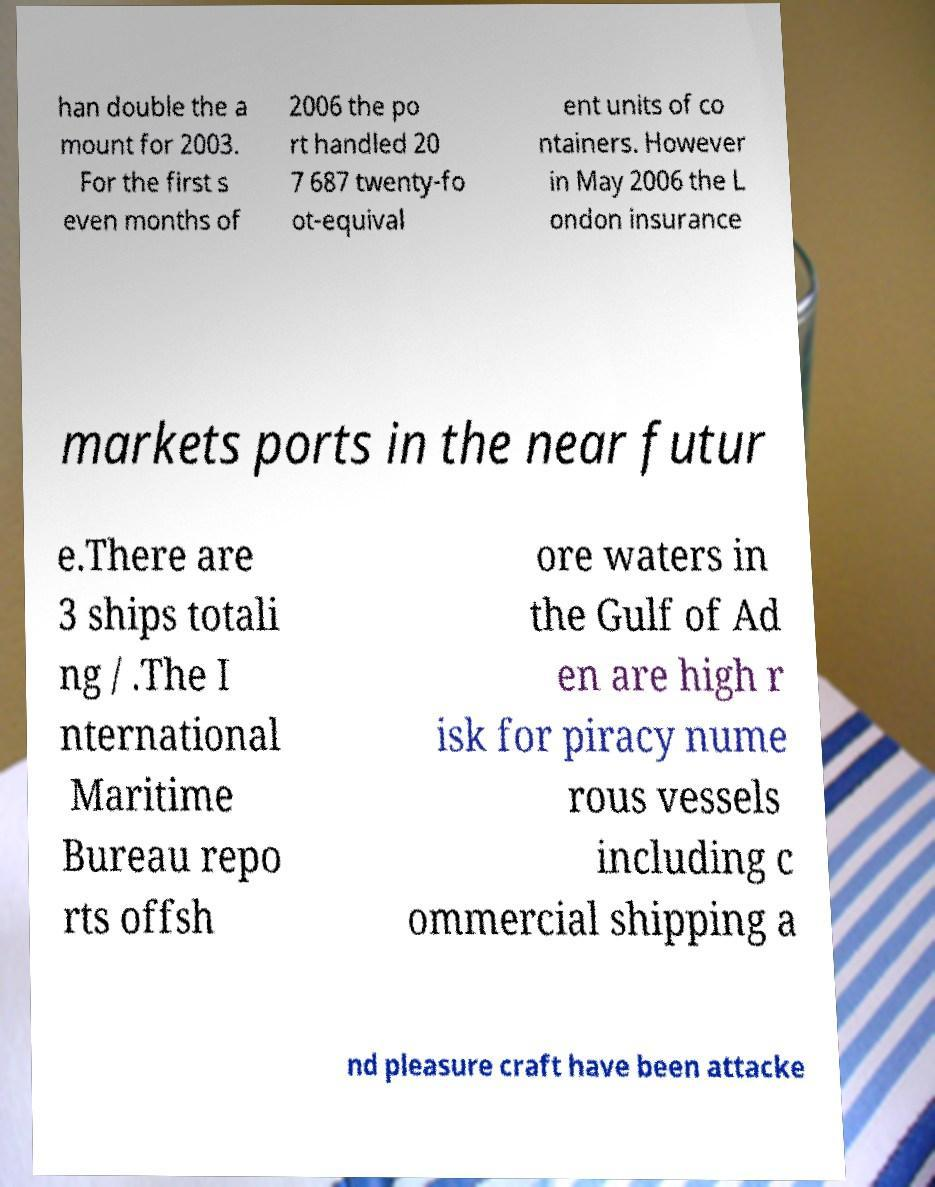There's text embedded in this image that I need extracted. Can you transcribe it verbatim? han double the a mount for 2003. For the first s even months of 2006 the po rt handled 20 7 687 twenty-fo ot-equival ent units of co ntainers. However in May 2006 the L ondon insurance markets ports in the near futur e.There are 3 ships totali ng / .The I nternational Maritime Bureau repo rts offsh ore waters in the Gulf of Ad en are high r isk for piracy nume rous vessels including c ommercial shipping a nd pleasure craft have been attacke 